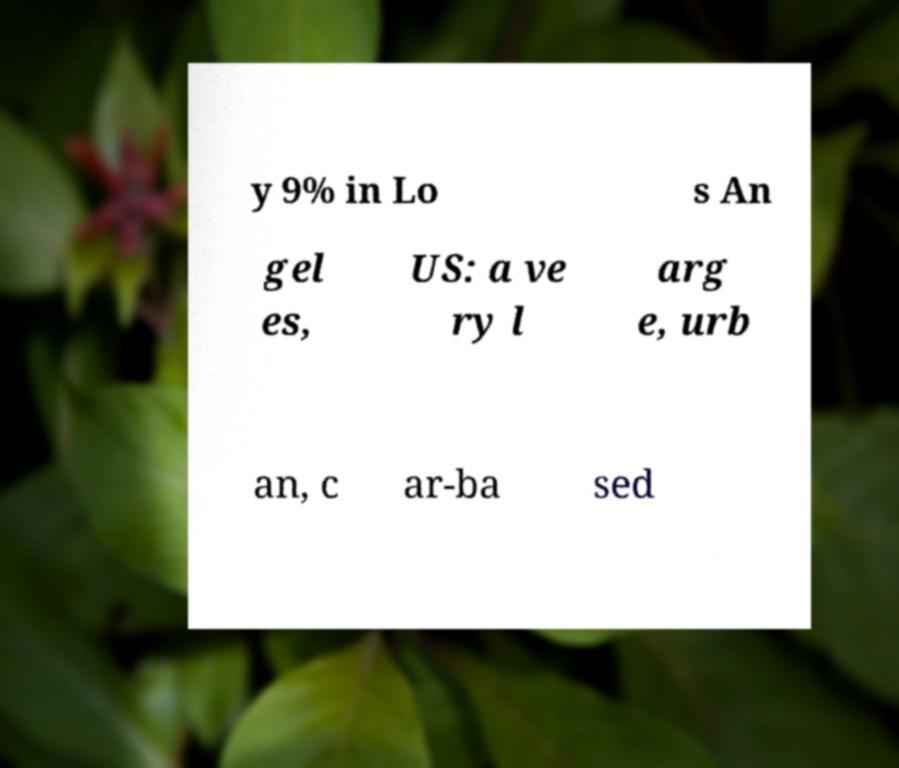Could you extract and type out the text from this image? y 9% in Lo s An gel es, US: a ve ry l arg e, urb an, c ar-ba sed 